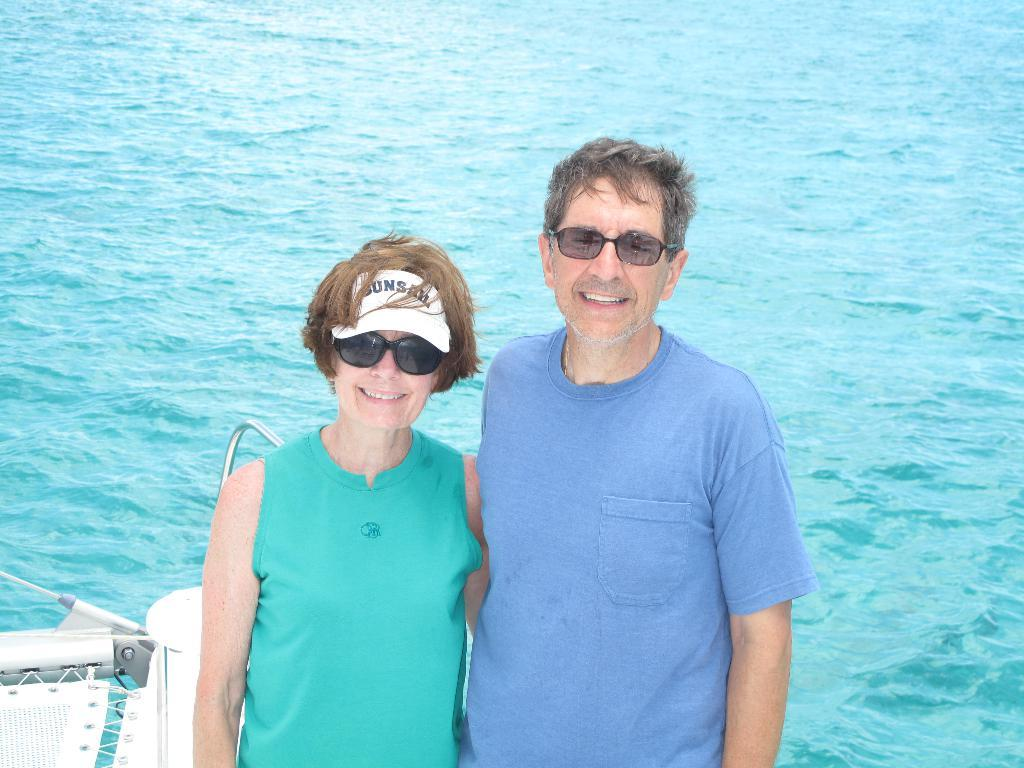Who can be seen in the image? There are people in the image. Can you describe the clothing of one of the individuals? A lady is wearing a cap in the image. What is located at the left bottom of the image? There is an object at the left bottom of the image. What natural feature is visible in the image? The sea is visible in the image. What type of key is being used by the maid in the image? There is no maid or key present in the image. What is the friction level between the people and the sea in the image? The image does not provide information about the friction level between the people and the sea. 